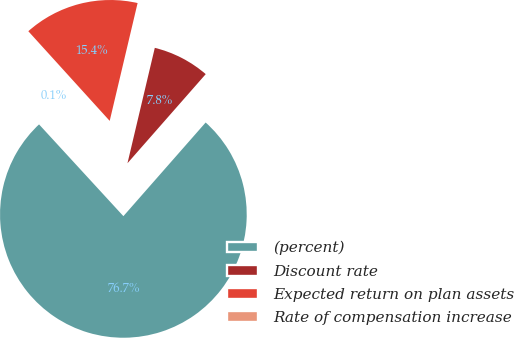Convert chart to OTSL. <chart><loc_0><loc_0><loc_500><loc_500><pie_chart><fcel>(percent)<fcel>Discount rate<fcel>Expected return on plan assets<fcel>Rate of compensation increase<nl><fcel>76.7%<fcel>7.77%<fcel>15.43%<fcel>0.1%<nl></chart> 